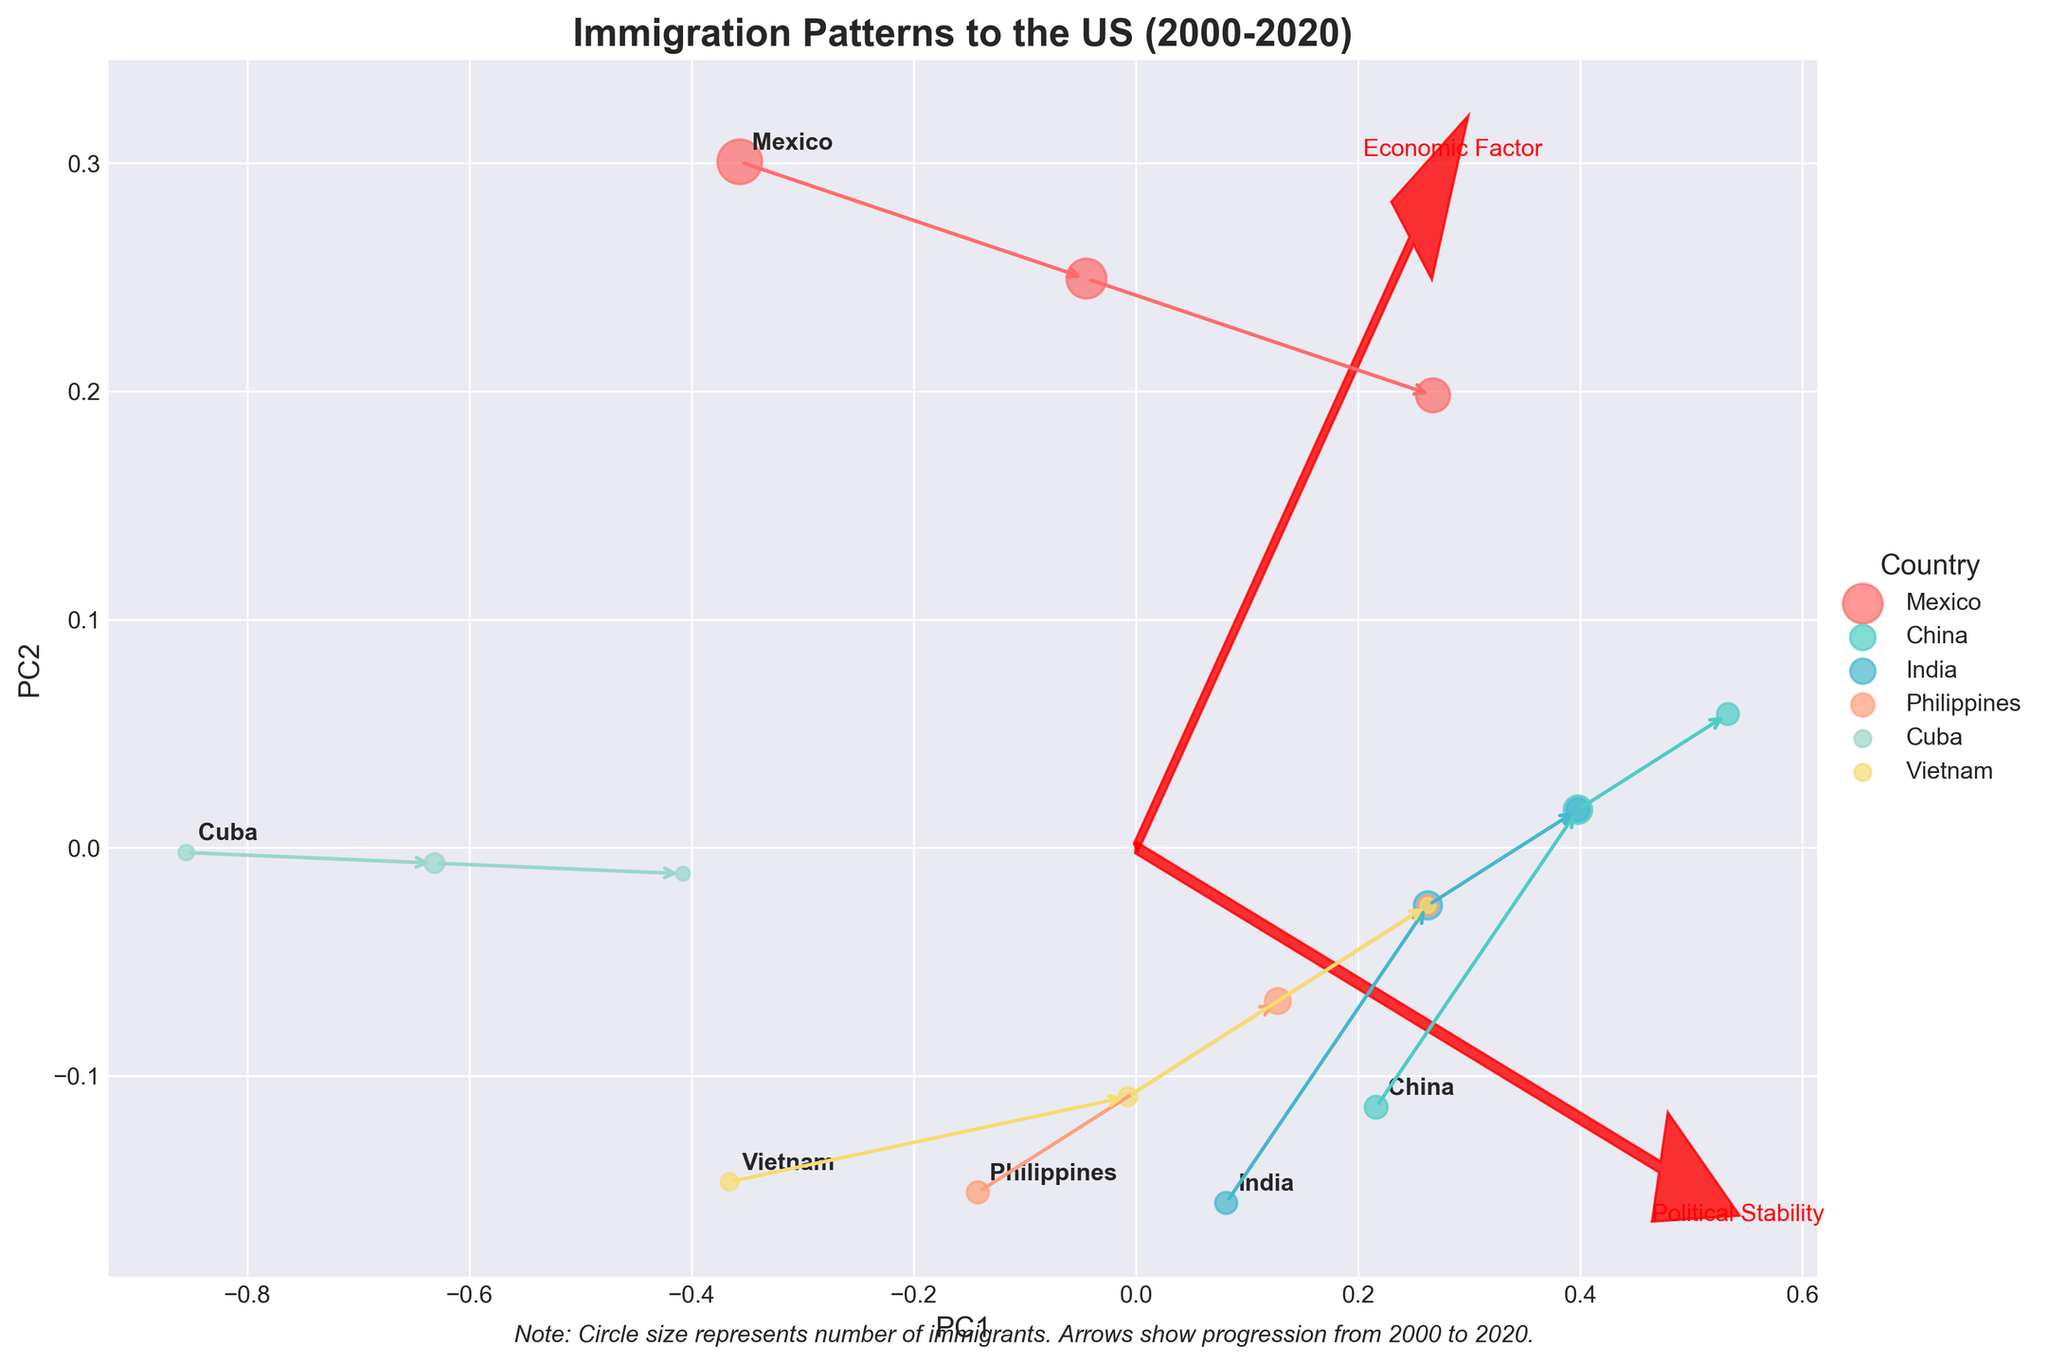How is the plot titled? The title is located at the top of the figure. It reads, "Immigration Patterns to the US (2000-2020)."
Answer: Immigration Patterns to the US (2000-2020) How many countries are represented in the plot? By looking at the legend on the right side of the plot, there are six different country labels.
Answer: 6 Which country has the largest size circle in 2020? The circle size reflects the number of immigrants. Mexico has the largest circle in 2020 as seen from the scatter plot.
Answer: Mexico How do economic factors affect political stability from 2000 to 2020 for China? China has an increasing trend in both economic factors and political stability, indicated by the plot data points moving along the positive direction on both PC1 and PC2 as time progresses.
Answer: Increasing trend Between 2010 and 2020, which country shows the largest decrease in the number of immigrants? Observing the plot, Mexico shows the largest decrease because the circle size representing 2020 is significantly smaller than 2010.
Answer: Mexico What does the arrow connecting two data points represent in the plot? The arrows indicate the progression of immigration patterns over time from 2000 to 2020 for each country.
Answer: Progression over time How do political stability and economic factor vectors orient in the plot? The plot displays two red arrows originating from the origin. Their directions reflect the principal components that align with political stability and economic factors.
Answer: Principal component directions Which country's data points are represented with the color closest to cyan? By observing the color scheme, China uses a color closest to cyan across its data points.
Answer: China In 2020, how does Cuba rank in terms of political stability compared to other countries? From the plot, Cuba has one of the lowest political stability scores in 2020, with a small positive value compared to other countries.
Answer: One of the lowest Which country shows the most significant improvement in economic factors between 2000 and 2020? By comparing the economic factors from the biplot, Philippines shows a significant positive progression over the two decades.
Answer: Philippines 